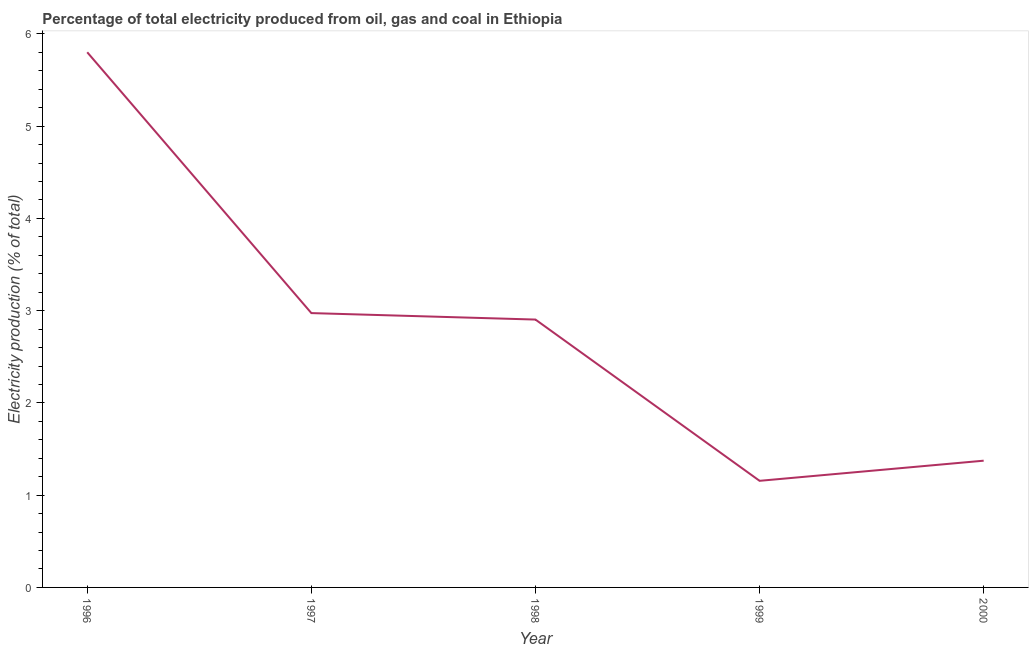What is the electricity production in 1996?
Ensure brevity in your answer.  5.8. Across all years, what is the maximum electricity production?
Keep it short and to the point. 5.8. Across all years, what is the minimum electricity production?
Your answer should be compact. 1.16. What is the sum of the electricity production?
Your response must be concise. 14.21. What is the difference between the electricity production in 1996 and 1998?
Your answer should be very brief. 2.9. What is the average electricity production per year?
Provide a short and direct response. 2.84. What is the median electricity production?
Make the answer very short. 2.9. In how many years, is the electricity production greater than 1.6 %?
Your response must be concise. 3. Do a majority of the years between 1999 and 1997 (inclusive) have electricity production greater than 1.2 %?
Provide a succinct answer. No. What is the ratio of the electricity production in 1999 to that in 2000?
Ensure brevity in your answer.  0.84. What is the difference between the highest and the second highest electricity production?
Your answer should be very brief. 2.83. What is the difference between the highest and the lowest electricity production?
Offer a very short reply. 4.65. In how many years, is the electricity production greater than the average electricity production taken over all years?
Keep it short and to the point. 3. Does the electricity production monotonically increase over the years?
Your answer should be very brief. No. What is the title of the graph?
Offer a terse response. Percentage of total electricity produced from oil, gas and coal in Ethiopia. What is the label or title of the X-axis?
Your response must be concise. Year. What is the label or title of the Y-axis?
Your response must be concise. Electricity production (% of total). What is the Electricity production (% of total) in 1996?
Ensure brevity in your answer.  5.8. What is the Electricity production (% of total) of 1997?
Ensure brevity in your answer.  2.97. What is the Electricity production (% of total) of 1998?
Ensure brevity in your answer.  2.9. What is the Electricity production (% of total) in 1999?
Keep it short and to the point. 1.16. What is the Electricity production (% of total) of 2000?
Keep it short and to the point. 1.37. What is the difference between the Electricity production (% of total) in 1996 and 1997?
Your answer should be very brief. 2.83. What is the difference between the Electricity production (% of total) in 1996 and 1998?
Your response must be concise. 2.9. What is the difference between the Electricity production (% of total) in 1996 and 1999?
Give a very brief answer. 4.65. What is the difference between the Electricity production (% of total) in 1996 and 2000?
Offer a very short reply. 4.43. What is the difference between the Electricity production (% of total) in 1997 and 1998?
Your answer should be compact. 0.07. What is the difference between the Electricity production (% of total) in 1997 and 1999?
Provide a short and direct response. 1.82. What is the difference between the Electricity production (% of total) in 1997 and 2000?
Keep it short and to the point. 1.6. What is the difference between the Electricity production (% of total) in 1998 and 1999?
Your answer should be compact. 1.75. What is the difference between the Electricity production (% of total) in 1998 and 2000?
Provide a short and direct response. 1.53. What is the difference between the Electricity production (% of total) in 1999 and 2000?
Your answer should be compact. -0.22. What is the ratio of the Electricity production (% of total) in 1996 to that in 1997?
Your answer should be very brief. 1.95. What is the ratio of the Electricity production (% of total) in 1996 to that in 1998?
Keep it short and to the point. 2. What is the ratio of the Electricity production (% of total) in 1996 to that in 1999?
Provide a short and direct response. 5.02. What is the ratio of the Electricity production (% of total) in 1996 to that in 2000?
Keep it short and to the point. 4.22. What is the ratio of the Electricity production (% of total) in 1997 to that in 1998?
Offer a very short reply. 1.02. What is the ratio of the Electricity production (% of total) in 1997 to that in 1999?
Give a very brief answer. 2.57. What is the ratio of the Electricity production (% of total) in 1997 to that in 2000?
Offer a terse response. 2.17. What is the ratio of the Electricity production (% of total) in 1998 to that in 1999?
Make the answer very short. 2.51. What is the ratio of the Electricity production (% of total) in 1998 to that in 2000?
Offer a terse response. 2.11. What is the ratio of the Electricity production (% of total) in 1999 to that in 2000?
Your answer should be compact. 0.84. 